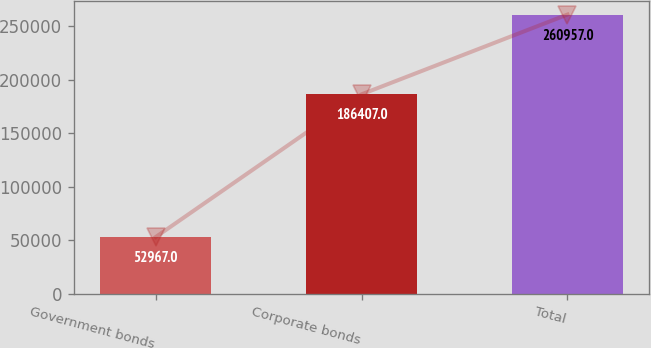Convert chart to OTSL. <chart><loc_0><loc_0><loc_500><loc_500><bar_chart><fcel>Government bonds<fcel>Corporate bonds<fcel>Total<nl><fcel>52967<fcel>186407<fcel>260957<nl></chart> 